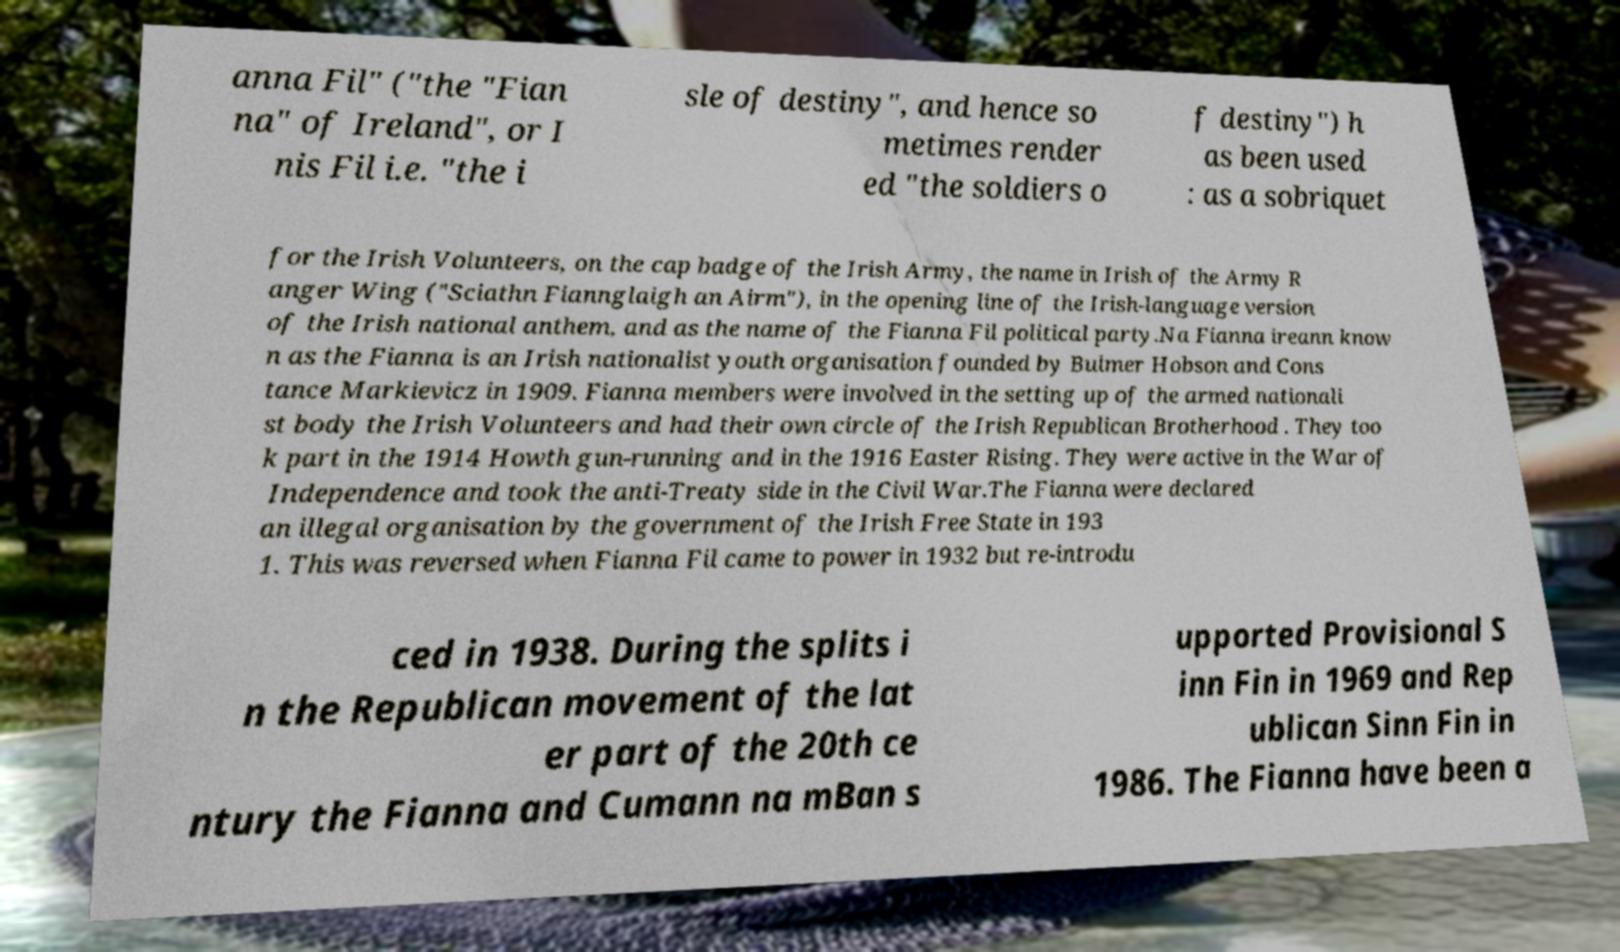I need the written content from this picture converted into text. Can you do that? anna Fil" ("the "Fian na" of Ireland", or I nis Fil i.e. "the i sle of destiny", and hence so metimes render ed "the soldiers o f destiny") h as been used : as a sobriquet for the Irish Volunteers, on the cap badge of the Irish Army, the name in Irish of the Army R anger Wing ("Sciathn Fiannglaigh an Airm"), in the opening line of the Irish-language version of the Irish national anthem, and as the name of the Fianna Fil political party.Na Fianna ireann know n as the Fianna is an Irish nationalist youth organisation founded by Bulmer Hobson and Cons tance Markievicz in 1909. Fianna members were involved in the setting up of the armed nationali st body the Irish Volunteers and had their own circle of the Irish Republican Brotherhood . They too k part in the 1914 Howth gun-running and in the 1916 Easter Rising. They were active in the War of Independence and took the anti-Treaty side in the Civil War.The Fianna were declared an illegal organisation by the government of the Irish Free State in 193 1. This was reversed when Fianna Fil came to power in 1932 but re-introdu ced in 1938. During the splits i n the Republican movement of the lat er part of the 20th ce ntury the Fianna and Cumann na mBan s upported Provisional S inn Fin in 1969 and Rep ublican Sinn Fin in 1986. The Fianna have been a 